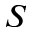<formula> <loc_0><loc_0><loc_500><loc_500>S</formula> 